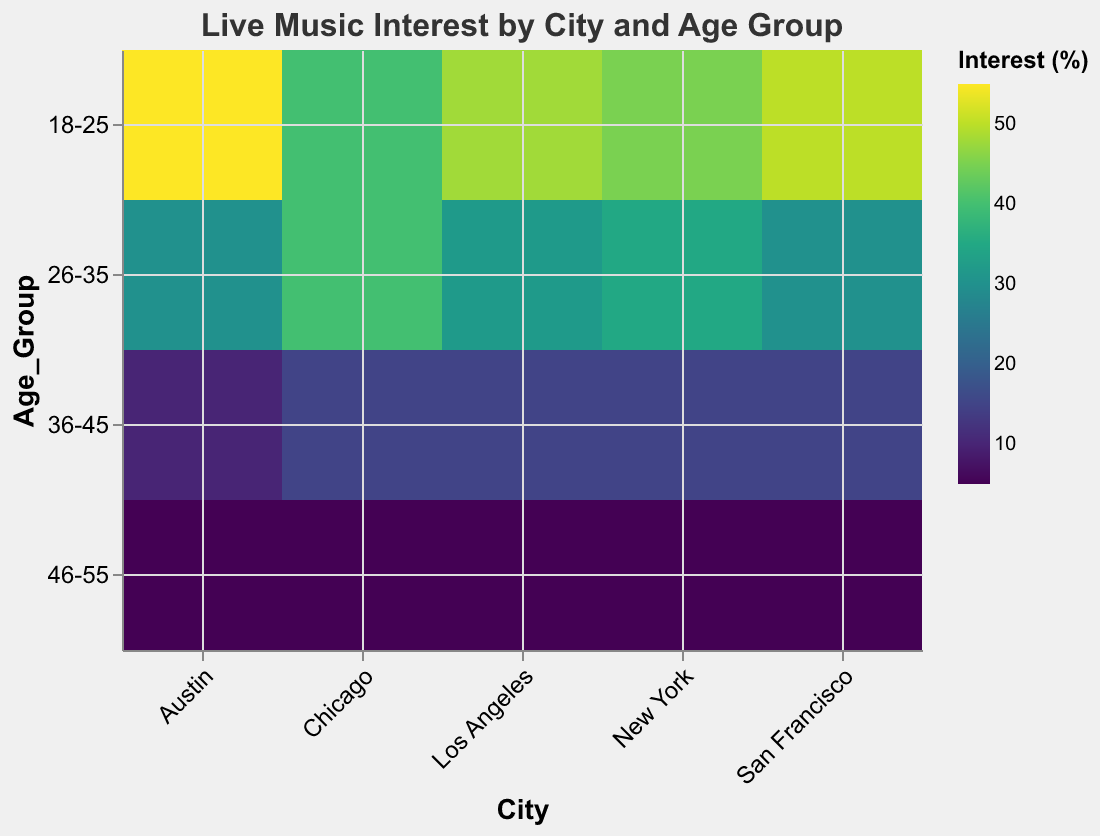What is the title of the figure? Look at the top of the figure where the title is displayed in bold. It says "Live Music Interest by City and Age Group."
Answer: Live Music Interest by City and Age Group Which city has the highest interest in live music for the age group 18-25? Find the column corresponding to each city and locate the cell for the 18-25 age group. Compare the percentages. Austin has 55%, which is the highest.
Answer: Austin What is the percentage interest in live music for the age group 46-55 in San Francisco? Look at the 'San Francisco' column and find the row corresponding to the age group '46-55'. The cell shows 5%.
Answer: 5% How does the interest in live music in the age group 36-45 in Chicago compare to that in Los Angeles? Locate the cells in the 'Chicago' and 'Los Angeles' columns for the age group '36-45.' Both have a percentage interest of 15%, so they are equal.
Answer: Equal Which age group in New York has the lowest interest in live music? Look at the 'New York' column and compare the cells for each age group. The age group '46-55' has the lowest percentage interest at 5%.
Answer: 46-55 What is the average interest in live music for the age group 26-35 across all cities? Find the row corresponding to the age group '26-35'. Sum the values: 35 (NY) + 30 (SF) + 40 (Chicago) + 30 (Austin) + 32 (LA) = 167. Divide by the number of cities (5). 167/5 = 33.4
Answer: 33.4 Is there a city where every age group has over 10% interest in live music? Check the cells for each city to see if any have every age group above 10%. All cities have the age group '46-55' with only 5%, so no city qualifies.
Answer: No Which city shows the most uniform interest across all age groups? Compare the variance in percentages for each city. Chicago has relatively uniform interests with values: 40, 40, 15, 5. The variation is smaller compared to other cities.
Answer: Chicago How does the interest in live music for the age group 18-25 in New York compare to that in Austin? Locate the cells in the 'New York' and 'Austin' columns for the age group 18-25. New York has 45%, Austin has 55%, so Austin has a higher interest.
Answer: Austin 